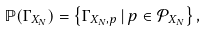<formula> <loc_0><loc_0><loc_500><loc_500>\mathbb { P } ( \Gamma _ { X _ { N } } ) = \left \{ \Gamma _ { X _ { N } , p } \, | \, p \in \mathcal { P } _ { X _ { N } } \right \} ,</formula> 